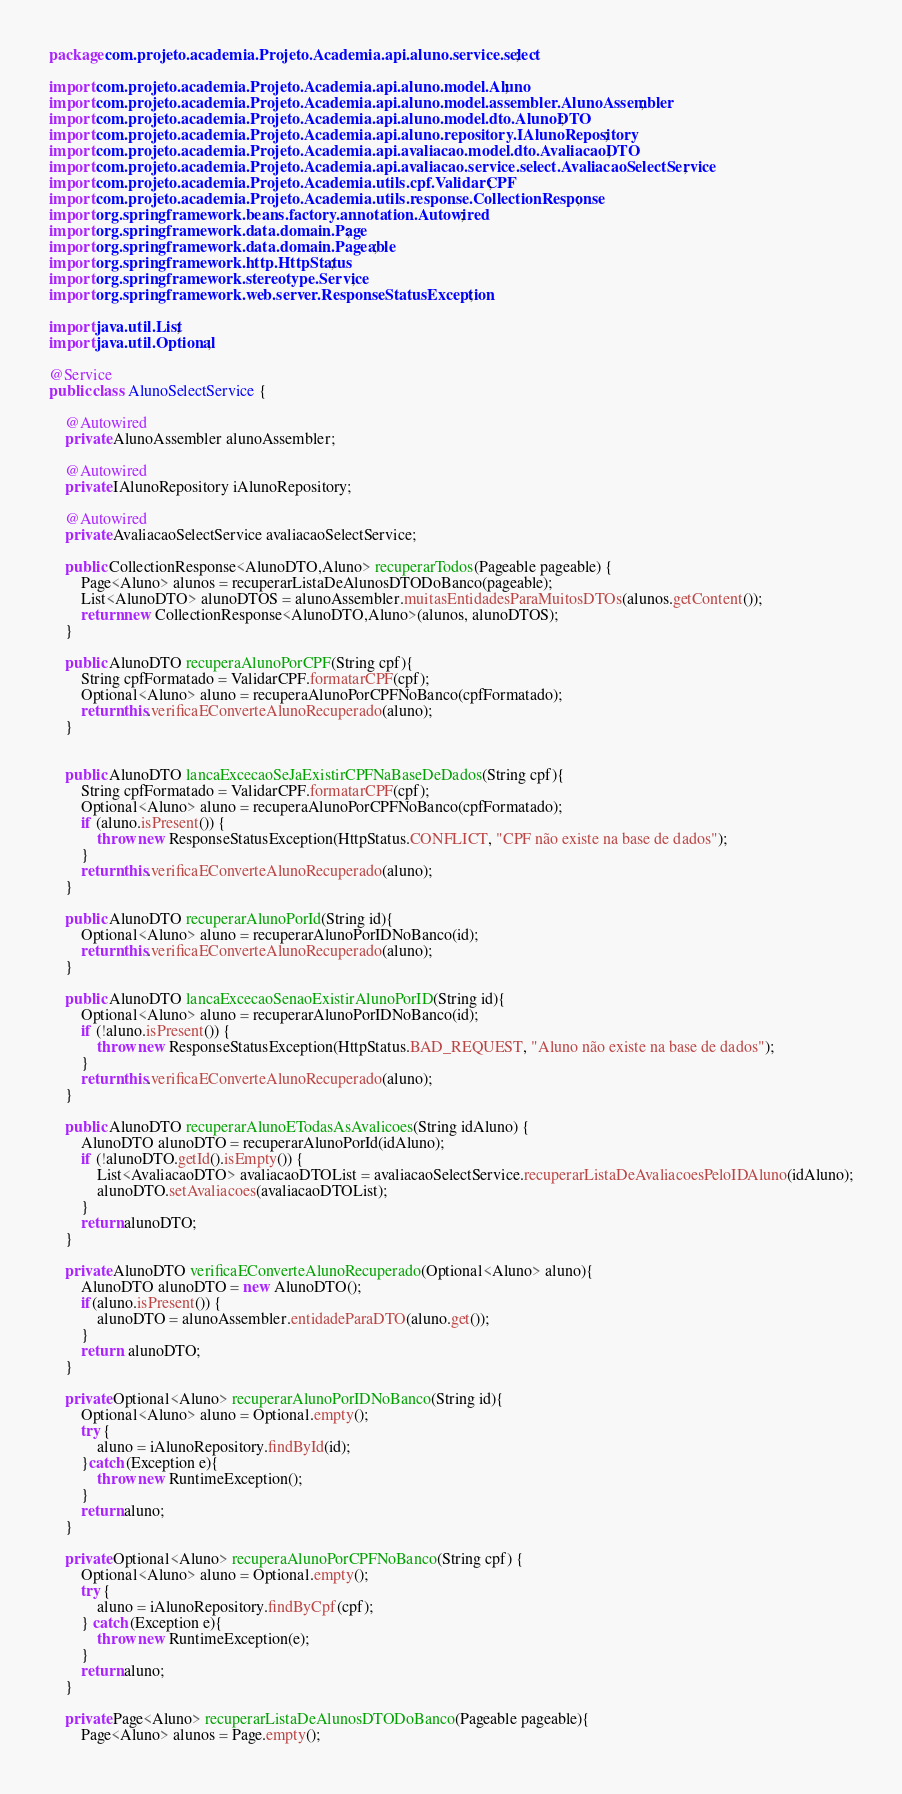<code> <loc_0><loc_0><loc_500><loc_500><_Java_>package com.projeto.academia.Projeto.Academia.api.aluno.service.select;

import com.projeto.academia.Projeto.Academia.api.aluno.model.Aluno;
import com.projeto.academia.Projeto.Academia.api.aluno.model.assembler.AlunoAssembler;
import com.projeto.academia.Projeto.Academia.api.aluno.model.dto.AlunoDTO;
import com.projeto.academia.Projeto.Academia.api.aluno.repository.IAlunoRepository;
import com.projeto.academia.Projeto.Academia.api.avaliacao.model.dto.AvaliacaoDTO;
import com.projeto.academia.Projeto.Academia.api.avaliacao.service.select.AvaliacaoSelectService;
import com.projeto.academia.Projeto.Academia.utils.cpf.ValidarCPF;
import com.projeto.academia.Projeto.Academia.utils.response.CollectionResponse;
import org.springframework.beans.factory.annotation.Autowired;
import org.springframework.data.domain.Page;
import org.springframework.data.domain.Pageable;
import org.springframework.http.HttpStatus;
import org.springframework.stereotype.Service;
import org.springframework.web.server.ResponseStatusException;

import java.util.List;
import java.util.Optional;

@Service
public class AlunoSelectService {

    @Autowired
    private AlunoAssembler alunoAssembler;

    @Autowired
    private IAlunoRepository iAlunoRepository;

    @Autowired
    private AvaliacaoSelectService avaliacaoSelectService;

    public CollectionResponse<AlunoDTO,Aluno> recuperarTodos(Pageable pageable) {
        Page<Aluno> alunos = recuperarListaDeAlunosDTODoBanco(pageable);
        List<AlunoDTO> alunoDTOS = alunoAssembler.muitasEntidadesParaMuitosDTOs(alunos.getContent());
        return new CollectionResponse<AlunoDTO,Aluno>(alunos, alunoDTOS);
    }

    public AlunoDTO recuperaAlunoPorCPF(String cpf){
        String cpfFormatado = ValidarCPF.formatarCPF(cpf);
        Optional<Aluno> aluno = recuperaAlunoPorCPFNoBanco(cpfFormatado);
        return this.verificaEConverteAlunoRecuperado(aluno);
    }


    public AlunoDTO lancaExcecaoSeJaExistirCPFNaBaseDeDados(String cpf){
        String cpfFormatado = ValidarCPF.formatarCPF(cpf);
        Optional<Aluno> aluno = recuperaAlunoPorCPFNoBanco(cpfFormatado);
        if (aluno.isPresent()) {
            throw new ResponseStatusException(HttpStatus.CONFLICT, "CPF não existe na base de dados");
        }
        return this.verificaEConverteAlunoRecuperado(aluno);
    }

    public AlunoDTO recuperarAlunoPorId(String id){
        Optional<Aluno> aluno = recuperarAlunoPorIDNoBanco(id);
        return this.verificaEConverteAlunoRecuperado(aluno);
    }

    public AlunoDTO lancaExcecaoSenaoExistirAlunoPorID(String id){
        Optional<Aluno> aluno = recuperarAlunoPorIDNoBanco(id);
        if (!aluno.isPresent()) {
            throw new ResponseStatusException(HttpStatus.BAD_REQUEST, "Aluno não existe na base de dados");
        }
        return this.verificaEConverteAlunoRecuperado(aluno);
    }

    public AlunoDTO recuperarAlunoETodasAsAvalicoes(String idAluno) {
        AlunoDTO alunoDTO = recuperarAlunoPorId(idAluno);
        if (!alunoDTO.getId().isEmpty()) {
            List<AvaliacaoDTO> avaliacaoDTOList = avaliacaoSelectService.recuperarListaDeAvaliacoesPeloIDAluno(idAluno);
            alunoDTO.setAvaliacoes(avaliacaoDTOList);
        }
        return alunoDTO;
    }

    private AlunoDTO verificaEConverteAlunoRecuperado(Optional<Aluno> aluno){
        AlunoDTO alunoDTO = new AlunoDTO();
        if(aluno.isPresent()) {
            alunoDTO = alunoAssembler.entidadeParaDTO(aluno.get());
        }
        return  alunoDTO;
    }

    private Optional<Aluno> recuperarAlunoPorIDNoBanco(String id){
        Optional<Aluno> aluno = Optional.empty();
        try {
            aluno = iAlunoRepository.findById(id);
        }catch (Exception e){
            throw new RuntimeException();
        }
        return aluno;
    }

    private Optional<Aluno> recuperaAlunoPorCPFNoBanco(String cpf) {
        Optional<Aluno> aluno = Optional.empty();
        try {
            aluno = iAlunoRepository.findByCpf(cpf);
        } catch (Exception e){
            throw new RuntimeException(e);
        }
        return aluno;
    }

    private Page<Aluno> recuperarListaDeAlunosDTODoBanco(Pageable pageable){
        Page<Aluno> alunos = Page.empty();</code> 